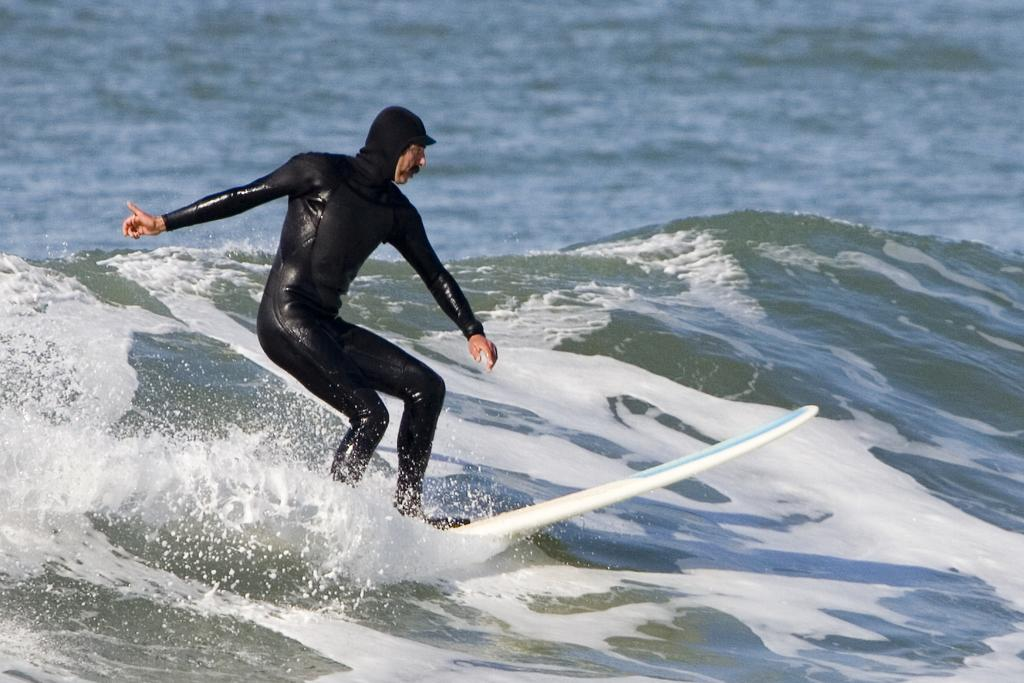Who is present in the image? There is a man in the image. What is the man doing in the image? The man is standing on a surface. What is the man wearing in the image? The man is wearing a black swimsuit. What can be seen in the background of the image? There is a heavy tide in the ocean. What type of chalk is the man using to draw on the sand in the image? There is no chalk present in the image, and the man is not drawing on the sand. 